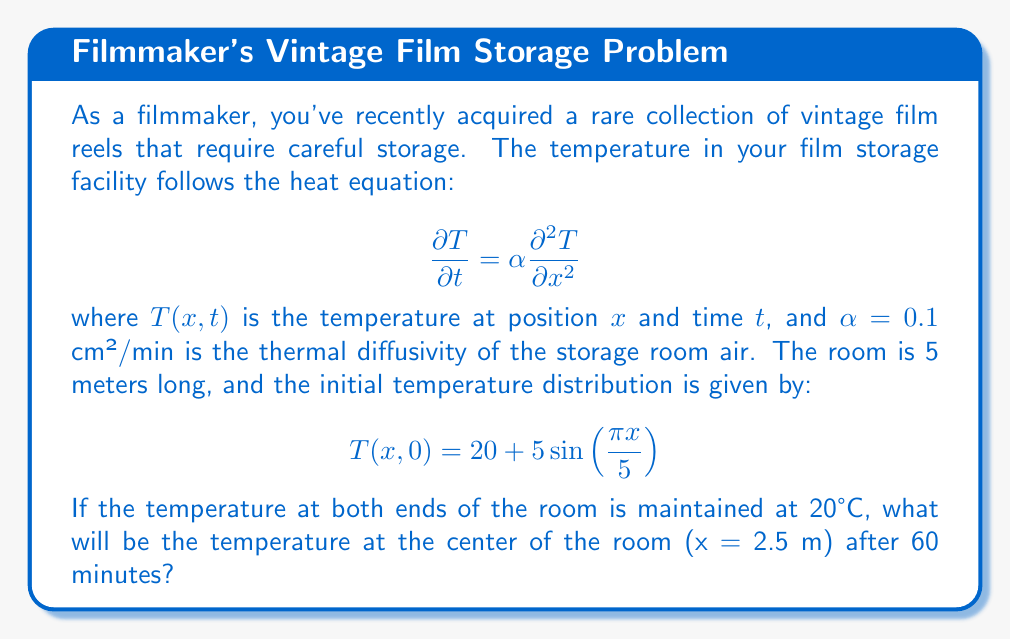What is the answer to this math problem? To solve this problem, we need to use the solution to the heat equation with the given initial and boundary conditions. The solution takes the form:

$$T(x,t) = 20 + \sum_{n=1}^{\infty} B_n \sin(\frac{n\pi x}{L})e^{-\alpha(\frac{n\pi}{L})^2t}$$

Where $L = 5$ m is the length of the room.

Step 1: Find $B_n$
We need to match the initial condition:
$$20 + 5\sin(\frac{\pi x}{5}) = 20 + \sum_{n=1}^{\infty} B_n \sin(\frac{n\pi x}{5})$$

This means $B_1 = 5$ and $B_n = 0$ for $n > 1$.

Step 2: Write the solution
$$T(x,t) = 20 + 5\sin(\frac{\pi x}{5})e^{-\alpha(\frac{\pi}{5})^2t}$$

Step 3: Calculate the temperature at the center (x = 2.5 m) after 60 minutes
$$\begin{align*}
T(2.5, 60) &= 20 + 5\sin(\frac{\pi \cdot 2.5}{5})e^{-0.1(\frac{\pi}{5})^2 \cdot 60} \\
&= 20 + 5\sin(\frac{\pi}{2})e^{-0.1(\frac{\pi}{5})^2 \cdot 60} \\
&= 20 + 5 \cdot 1 \cdot e^{-0.24\pi^2} \\
&= 20 + 5e^{-2.3562} \\
&\approx 20.4815 \text{ °C}
\end{align*}$$
Answer: 20.48°C 